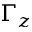Convert formula to latex. <formula><loc_0><loc_0><loc_500><loc_500>\Gamma _ { z }</formula> 